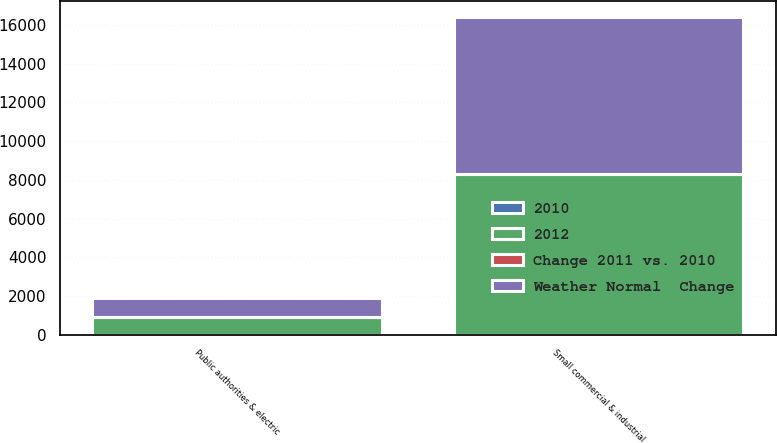<chart> <loc_0><loc_0><loc_500><loc_500><stacked_bar_chart><ecel><fcel>Small commercial & industrial<fcel>Public authorities & electric<nl><fcel>Weather Normal  Change<fcel>8063<fcel>943<nl><fcel>2012<fcel>8321<fcel>945<nl><fcel>2010<fcel>3.1<fcel>0.2<nl><fcel>Change 2011 vs. 2010<fcel>2.3<fcel>0.2<nl></chart> 